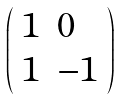Convert formula to latex. <formula><loc_0><loc_0><loc_500><loc_500>\left ( \begin{array} { l l } { 1 } & { 0 } \\ { 1 } & { - 1 } \end{array} \right )</formula> 